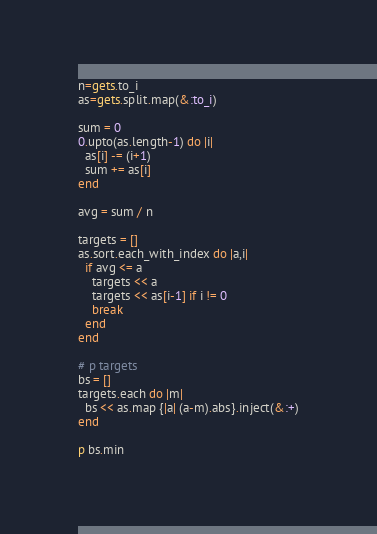Convert code to text. <code><loc_0><loc_0><loc_500><loc_500><_Ruby_>n=gets.to_i
as=gets.split.map(&:to_i)

sum = 0
0.upto(as.length-1) do |i|
  as[i] -= (i+1)
  sum += as[i]
end

avg = sum / n

targets = []
as.sort.each_with_index do |a,i|
  if avg <= a
    targets << a
    targets << as[i-1] if i != 0
    break
  end
end

# p targets
bs = []
targets.each do |m|
  bs << as.map {|a| (a-m).abs}.inject(&:+)
end

p bs.min</code> 